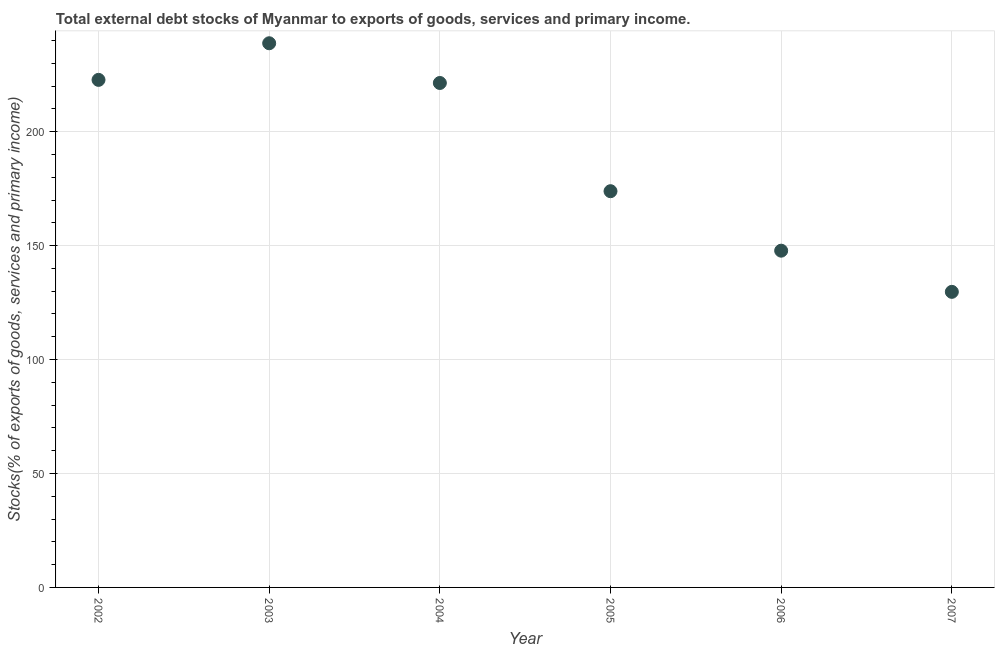What is the external debt stocks in 2004?
Provide a succinct answer. 221.39. Across all years, what is the maximum external debt stocks?
Give a very brief answer. 238.82. Across all years, what is the minimum external debt stocks?
Give a very brief answer. 129.72. In which year was the external debt stocks maximum?
Provide a short and direct response. 2003. In which year was the external debt stocks minimum?
Give a very brief answer. 2007. What is the sum of the external debt stocks?
Give a very brief answer. 1134.37. What is the difference between the external debt stocks in 2003 and 2004?
Your response must be concise. 17.44. What is the average external debt stocks per year?
Your response must be concise. 189.06. What is the median external debt stocks?
Keep it short and to the point. 197.64. What is the ratio of the external debt stocks in 2002 to that in 2006?
Your answer should be compact. 1.51. Is the external debt stocks in 2005 less than that in 2007?
Offer a terse response. No. What is the difference between the highest and the second highest external debt stocks?
Your response must be concise. 16.07. Is the sum of the external debt stocks in 2004 and 2005 greater than the maximum external debt stocks across all years?
Offer a terse response. Yes. What is the difference between the highest and the lowest external debt stocks?
Offer a very short reply. 109.1. In how many years, is the external debt stocks greater than the average external debt stocks taken over all years?
Offer a very short reply. 3. How many dotlines are there?
Your response must be concise. 1. How many years are there in the graph?
Your response must be concise. 6. Does the graph contain any zero values?
Your response must be concise. No. Does the graph contain grids?
Your response must be concise. Yes. What is the title of the graph?
Offer a terse response. Total external debt stocks of Myanmar to exports of goods, services and primary income. What is the label or title of the X-axis?
Your response must be concise. Year. What is the label or title of the Y-axis?
Make the answer very short. Stocks(% of exports of goods, services and primary income). What is the Stocks(% of exports of goods, services and primary income) in 2002?
Your answer should be very brief. 222.75. What is the Stocks(% of exports of goods, services and primary income) in 2003?
Offer a very short reply. 238.82. What is the Stocks(% of exports of goods, services and primary income) in 2004?
Ensure brevity in your answer.  221.39. What is the Stocks(% of exports of goods, services and primary income) in 2005?
Keep it short and to the point. 173.9. What is the Stocks(% of exports of goods, services and primary income) in 2006?
Provide a succinct answer. 147.79. What is the Stocks(% of exports of goods, services and primary income) in 2007?
Offer a terse response. 129.72. What is the difference between the Stocks(% of exports of goods, services and primary income) in 2002 and 2003?
Offer a very short reply. -16.07. What is the difference between the Stocks(% of exports of goods, services and primary income) in 2002 and 2004?
Offer a terse response. 1.37. What is the difference between the Stocks(% of exports of goods, services and primary income) in 2002 and 2005?
Provide a short and direct response. 48.86. What is the difference between the Stocks(% of exports of goods, services and primary income) in 2002 and 2006?
Ensure brevity in your answer.  74.96. What is the difference between the Stocks(% of exports of goods, services and primary income) in 2002 and 2007?
Make the answer very short. 93.03. What is the difference between the Stocks(% of exports of goods, services and primary income) in 2003 and 2004?
Give a very brief answer. 17.44. What is the difference between the Stocks(% of exports of goods, services and primary income) in 2003 and 2005?
Offer a very short reply. 64.93. What is the difference between the Stocks(% of exports of goods, services and primary income) in 2003 and 2006?
Provide a short and direct response. 91.03. What is the difference between the Stocks(% of exports of goods, services and primary income) in 2003 and 2007?
Your answer should be compact. 109.1. What is the difference between the Stocks(% of exports of goods, services and primary income) in 2004 and 2005?
Provide a short and direct response. 47.49. What is the difference between the Stocks(% of exports of goods, services and primary income) in 2004 and 2006?
Offer a terse response. 73.6. What is the difference between the Stocks(% of exports of goods, services and primary income) in 2004 and 2007?
Offer a terse response. 91.67. What is the difference between the Stocks(% of exports of goods, services and primary income) in 2005 and 2006?
Provide a short and direct response. 26.1. What is the difference between the Stocks(% of exports of goods, services and primary income) in 2005 and 2007?
Make the answer very short. 44.18. What is the difference between the Stocks(% of exports of goods, services and primary income) in 2006 and 2007?
Keep it short and to the point. 18.07. What is the ratio of the Stocks(% of exports of goods, services and primary income) in 2002 to that in 2003?
Offer a terse response. 0.93. What is the ratio of the Stocks(% of exports of goods, services and primary income) in 2002 to that in 2005?
Ensure brevity in your answer.  1.28. What is the ratio of the Stocks(% of exports of goods, services and primary income) in 2002 to that in 2006?
Make the answer very short. 1.51. What is the ratio of the Stocks(% of exports of goods, services and primary income) in 2002 to that in 2007?
Your response must be concise. 1.72. What is the ratio of the Stocks(% of exports of goods, services and primary income) in 2003 to that in 2004?
Offer a very short reply. 1.08. What is the ratio of the Stocks(% of exports of goods, services and primary income) in 2003 to that in 2005?
Your answer should be compact. 1.37. What is the ratio of the Stocks(% of exports of goods, services and primary income) in 2003 to that in 2006?
Your answer should be very brief. 1.62. What is the ratio of the Stocks(% of exports of goods, services and primary income) in 2003 to that in 2007?
Your answer should be compact. 1.84. What is the ratio of the Stocks(% of exports of goods, services and primary income) in 2004 to that in 2005?
Provide a short and direct response. 1.27. What is the ratio of the Stocks(% of exports of goods, services and primary income) in 2004 to that in 2006?
Ensure brevity in your answer.  1.5. What is the ratio of the Stocks(% of exports of goods, services and primary income) in 2004 to that in 2007?
Your answer should be very brief. 1.71. What is the ratio of the Stocks(% of exports of goods, services and primary income) in 2005 to that in 2006?
Offer a terse response. 1.18. What is the ratio of the Stocks(% of exports of goods, services and primary income) in 2005 to that in 2007?
Offer a terse response. 1.34. What is the ratio of the Stocks(% of exports of goods, services and primary income) in 2006 to that in 2007?
Provide a succinct answer. 1.14. 